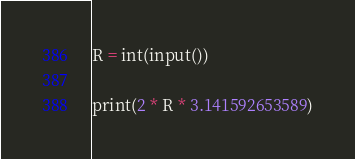Convert code to text. <code><loc_0><loc_0><loc_500><loc_500><_Python_>R = int(input())

print(2 * R * 3.141592653589)</code> 